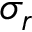Convert formula to latex. <formula><loc_0><loc_0><loc_500><loc_500>\sigma _ { r }</formula> 